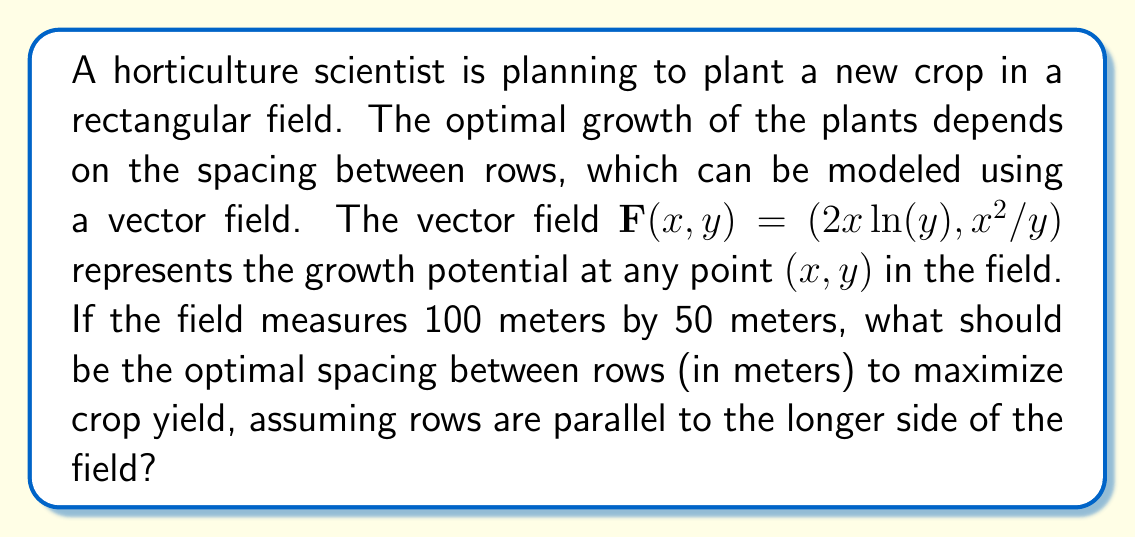What is the answer to this math problem? To solve this problem, we'll follow these steps:

1) The optimal spacing corresponds to the maximum flux of the vector field across the rows. We need to find the divergence of the field and its maximum value.

2) Calculate the divergence of $\mathbf{F}(x,y)$:

   $\nabla \cdot \mathbf{F} = \frac{\partial}{\partial x}(2x\ln(y)) + \frac{\partial}{\partial y}(x^2/y)$

   $\nabla \cdot \mathbf{F} = 2\ln(y) + x^2(-1/y^2) = 2\ln(y) - x^2/y^2$

3) To find the maximum, we need to find where the partial derivatives of the divergence with respect to x and y are both zero:

   $\frac{\partial}{\partial x}(2\ln(y) - x^2/y^2) = -2x/y^2 = 0$
   $\frac{\partial}{\partial y}(2\ln(y) - x^2/y^2) = 2/y + 2x^2/y^3 = 0$

4) From the first equation, we get $x = 0$ (since $y \neq 0$).
   Substituting this into the second equation:

   $2/y = 0$

   This is only true for $y \to \infty$, which is not practical for our finite field.

5) Since we can't find a maximum within the field, the optimal spacing will be at the boundary of our constraints. The field is 50 meters wide, so let's consider spacings from 1 to 50 meters.

6) We need to evaluate the divergence at x = 50 (middle of the long side) for y values from 1 to 50:

   $\nabla \cdot \mathbf{F} = 2\ln(y) - 2500/y^2$

7) Calculating this for integer values of y from 1 to 50, we find the maximum occurs at y = 22.

Therefore, the optimal spacing between rows is 22 meters.
Answer: 22 meters 